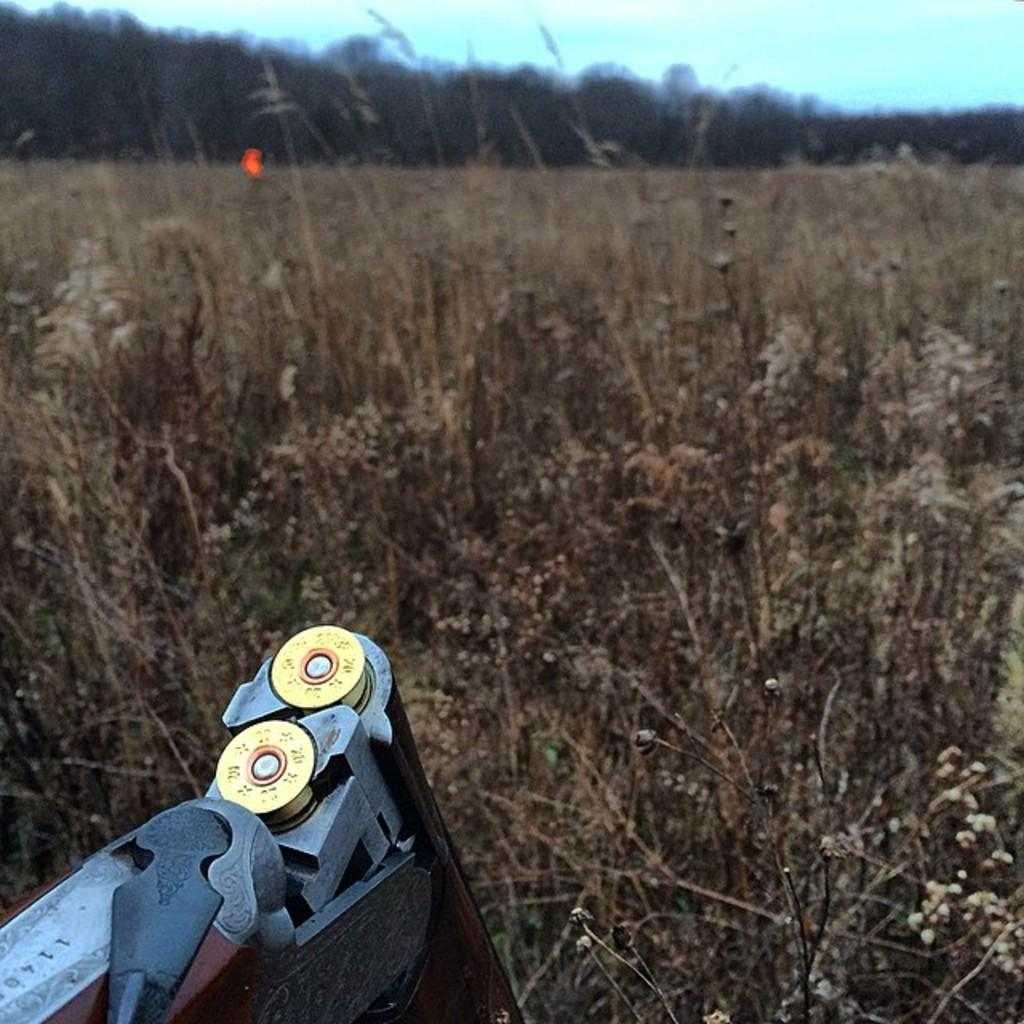What is the main object in the front of the image? There is a gun in the front of the image. What type of vegetation can be seen in the background of the image? There is dry grass in the background of the image. What else is visible in the background of the image? There are trees in the background of the image. Where is the sink located in the image? There is no sink present in the image. What type of spark can be seen coming from the gun in the image? There is no spark coming from the gun in the image. 